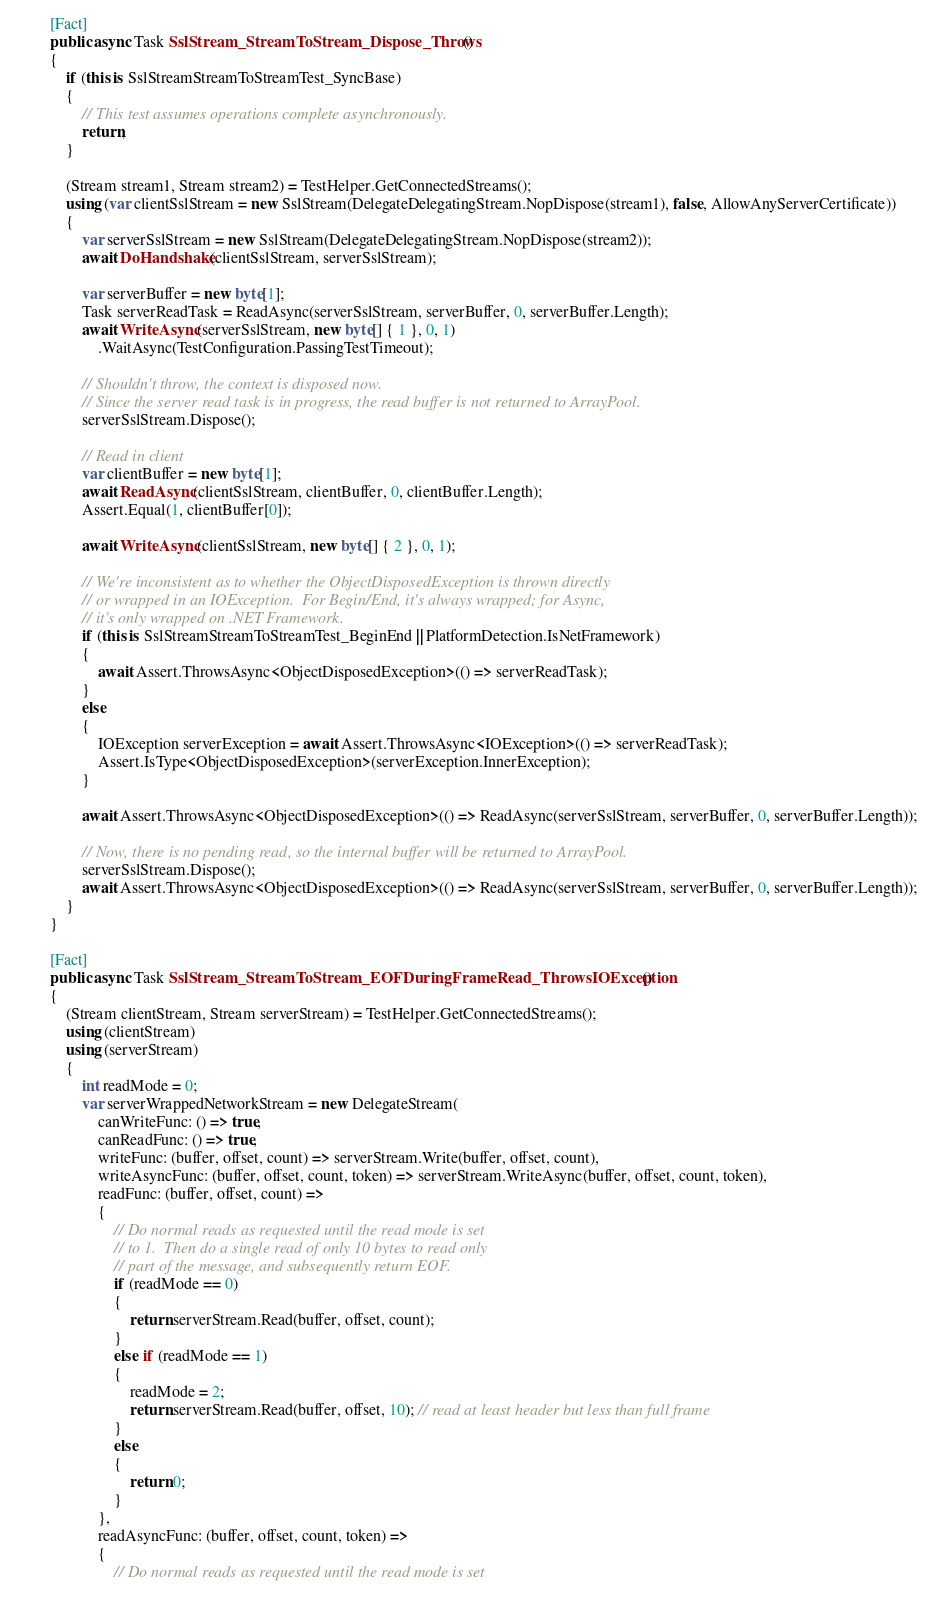Convert code to text. <code><loc_0><loc_0><loc_500><loc_500><_C#_>

        [Fact]
        public async Task SslStream_StreamToStream_Dispose_Throws()
        {
            if (this is SslStreamStreamToStreamTest_SyncBase)
            {
                // This test assumes operations complete asynchronously.
                return;
            }

            (Stream stream1, Stream stream2) = TestHelper.GetConnectedStreams();
            using (var clientSslStream = new SslStream(DelegateDelegatingStream.NopDispose(stream1), false, AllowAnyServerCertificate))
            {
                var serverSslStream = new SslStream(DelegateDelegatingStream.NopDispose(stream2));
                await DoHandshake(clientSslStream, serverSslStream);

                var serverBuffer = new byte[1];
                Task serverReadTask = ReadAsync(serverSslStream, serverBuffer, 0, serverBuffer.Length);
                await WriteAsync(serverSslStream, new byte[] { 1 }, 0, 1)
                    .WaitAsync(TestConfiguration.PassingTestTimeout);

                // Shouldn't throw, the context is disposed now.
                // Since the server read task is in progress, the read buffer is not returned to ArrayPool.
                serverSslStream.Dispose();

                // Read in client
                var clientBuffer = new byte[1];
                await ReadAsync(clientSslStream, clientBuffer, 0, clientBuffer.Length);
                Assert.Equal(1, clientBuffer[0]);

                await WriteAsync(clientSslStream, new byte[] { 2 }, 0, 1);

                // We're inconsistent as to whether the ObjectDisposedException is thrown directly
                // or wrapped in an IOException.  For Begin/End, it's always wrapped; for Async,
                // it's only wrapped on .NET Framework.
                if (this is SslStreamStreamToStreamTest_BeginEnd || PlatformDetection.IsNetFramework)
                {
                    await Assert.ThrowsAsync<ObjectDisposedException>(() => serverReadTask);
                }
                else
                {
                    IOException serverException = await Assert.ThrowsAsync<IOException>(() => serverReadTask);
                    Assert.IsType<ObjectDisposedException>(serverException.InnerException);
                }

                await Assert.ThrowsAsync<ObjectDisposedException>(() => ReadAsync(serverSslStream, serverBuffer, 0, serverBuffer.Length));

                // Now, there is no pending read, so the internal buffer will be returned to ArrayPool.
                serverSslStream.Dispose();
                await Assert.ThrowsAsync<ObjectDisposedException>(() => ReadAsync(serverSslStream, serverBuffer, 0, serverBuffer.Length));
            }
        }

        [Fact]
        public async Task SslStream_StreamToStream_EOFDuringFrameRead_ThrowsIOException()
        {
            (Stream clientStream, Stream serverStream) = TestHelper.GetConnectedStreams();
            using (clientStream)
            using (serverStream)
            {
                int readMode = 0;
                var serverWrappedNetworkStream = new DelegateStream(
                    canWriteFunc: () => true,
                    canReadFunc: () => true,
                    writeFunc: (buffer, offset, count) => serverStream.Write(buffer, offset, count),
                    writeAsyncFunc: (buffer, offset, count, token) => serverStream.WriteAsync(buffer, offset, count, token),
                    readFunc: (buffer, offset, count) =>
                    {
                        // Do normal reads as requested until the read mode is set
                        // to 1.  Then do a single read of only 10 bytes to read only
                        // part of the message, and subsequently return EOF.
                        if (readMode == 0)
                        {
                            return serverStream.Read(buffer, offset, count);
                        }
                        else if (readMode == 1)
                        {
                            readMode = 2;
                            return serverStream.Read(buffer, offset, 10); // read at least header but less than full frame
                        }
                        else
                        {
                            return 0;
                        }
                    },
                    readAsyncFunc: (buffer, offset, count, token) =>
                    {
                        // Do normal reads as requested until the read mode is set</code> 